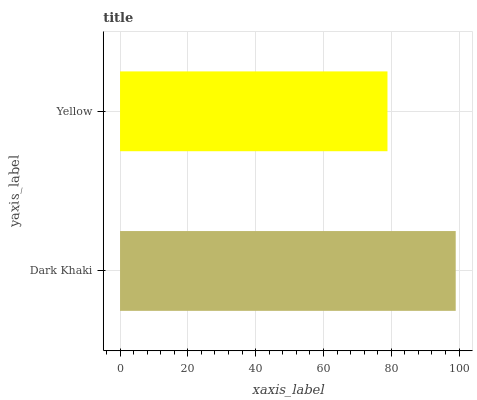Is Yellow the minimum?
Answer yes or no. Yes. Is Dark Khaki the maximum?
Answer yes or no. Yes. Is Yellow the maximum?
Answer yes or no. No. Is Dark Khaki greater than Yellow?
Answer yes or no. Yes. Is Yellow less than Dark Khaki?
Answer yes or no. Yes. Is Yellow greater than Dark Khaki?
Answer yes or no. No. Is Dark Khaki less than Yellow?
Answer yes or no. No. Is Dark Khaki the high median?
Answer yes or no. Yes. Is Yellow the low median?
Answer yes or no. Yes. Is Yellow the high median?
Answer yes or no. No. Is Dark Khaki the low median?
Answer yes or no. No. 